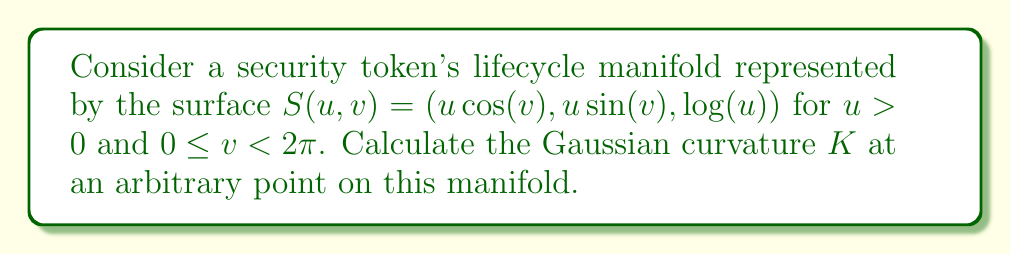Solve this math problem. To calculate the Gaussian curvature, we'll follow these steps:

1) First, we need to compute the coefficients of the first fundamental form:
   $E = \frac{\partial S}{\partial u} \cdot \frac{\partial S}{\partial u}$
   $F = \frac{\partial S}{\partial u} \cdot \frac{\partial S}{\partial v}$
   $G = \frac{\partial S}{\partial v} \cdot \frac{\partial S}{\partial v}$

   $\frac{\partial S}{\partial u} = (\cos(v), \sin(v), \frac{1}{u})$
   $\frac{\partial S}{\partial v} = (-u\sin(v), u\cos(v), 0)$

   $E = \cos^2(v) + \sin^2(v) + \frac{1}{u^2} = 1 + \frac{1}{u^2}$
   $F = -u\sin(v)\cos(v) + u\sin(v)\cos(v) = 0$
   $G = u^2\sin^2(v) + u^2\cos^2(v) = u^2$

2) Next, we compute the coefficients of the second fundamental form:
   $e = \frac{\partial^2 S}{\partial u^2} \cdot N$
   $f = \frac{\partial^2 S}{\partial u\partial v} \cdot N$
   $g = \frac{\partial^2 S}{\partial v^2} \cdot N$

   Where $N$ is the unit normal vector:
   $N = \frac{\frac{\partial S}{\partial u} \times \frac{\partial S}{\partial v}}{|\frac{\partial S}{\partial u} \times \frac{\partial S}{\partial v}|}$

   $\frac{\partial S}{\partial u} \times \frac{\partial S}{\partial v} = (-\frac{\cos(v)}{u}, -\frac{\sin(v)}{u}, 1)$

   $|\frac{\partial S}{\partial u} \times \frac{\partial S}{\partial v}| = \sqrt{\frac{\cos^2(v)}{u^2} + \frac{\sin^2(v)}{u^2} + 1} = \sqrt{\frac{1}{u^2} + 1}$

   $N = \frac{(-\frac{\cos(v)}{u}, -\frac{\sin(v)}{u}, 1)}{\sqrt{\frac{1}{u^2} + 1}}$

   $\frac{\partial^2 S}{\partial u^2} = (0, 0, -\frac{1}{u^2})$
   $\frac{\partial^2 S}{\partial u\partial v} = (-\sin(v), \cos(v), 0)$
   $\frac{\partial^2 S}{\partial v^2} = (-u\cos(v), -u\sin(v), 0)$

   $e = \frac{-\frac{1}{u^2}}{\sqrt{\frac{1}{u^2} + 1}}$
   $f = 0$
   $g = \frac{-u}{\sqrt{\frac{1}{u^2} + 1}}$

3) The Gaussian curvature is given by:
   $K = \frac{eg - f^2}{EG - F^2}$

   Substituting the values:

   $K = \frac{\frac{-\frac{1}{u^2}}{\sqrt{\frac{1}{u^2} + 1}} \cdot \frac{-u}{\sqrt{\frac{1}{u^2} + 1}} - 0}{(1 + \frac{1}{u^2}) \cdot u^2 - 0}$

4) Simplifying:

   $K = \frac{\frac{1}{u^3(\frac{1}{u^2} + 1)}}{u^2 + 1} = \frac{1}{u^3(u^2 + 1)^2}$

This is the Gaussian curvature at any point $(u,v)$ on the security token's lifecycle manifold.
Answer: $K = \frac{1}{u^3(u^2 + 1)^2}$ 